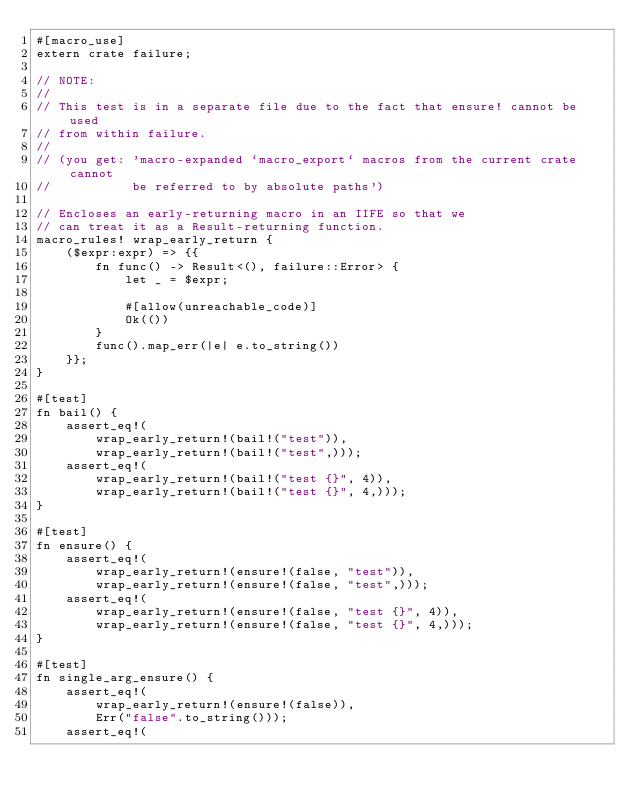<code> <loc_0><loc_0><loc_500><loc_500><_Rust_>#[macro_use]
extern crate failure;

// NOTE:
//
// This test is in a separate file due to the fact that ensure! cannot be used
// from within failure.
//
// (you get: 'macro-expanded `macro_export` macros from the current crate cannot
//           be referred to by absolute paths')

// Encloses an early-returning macro in an IIFE so that we
// can treat it as a Result-returning function.
macro_rules! wrap_early_return {
    ($expr:expr) => {{
        fn func() -> Result<(), failure::Error> {
            let _ = $expr;

            #[allow(unreachable_code)]
            Ok(())
        }
        func().map_err(|e| e.to_string())
    }};
}

#[test]
fn bail() {
    assert_eq!(
        wrap_early_return!(bail!("test")),
        wrap_early_return!(bail!("test",)));
    assert_eq!(
        wrap_early_return!(bail!("test {}", 4)),
        wrap_early_return!(bail!("test {}", 4,)));
}

#[test]
fn ensure() {
    assert_eq!(
        wrap_early_return!(ensure!(false, "test")),
        wrap_early_return!(ensure!(false, "test",)));
    assert_eq!(
        wrap_early_return!(ensure!(false, "test {}", 4)),
        wrap_early_return!(ensure!(false, "test {}", 4,)));
}

#[test]
fn single_arg_ensure() {
    assert_eq!(
        wrap_early_return!(ensure!(false)),
        Err("false".to_string()));
    assert_eq!(</code> 